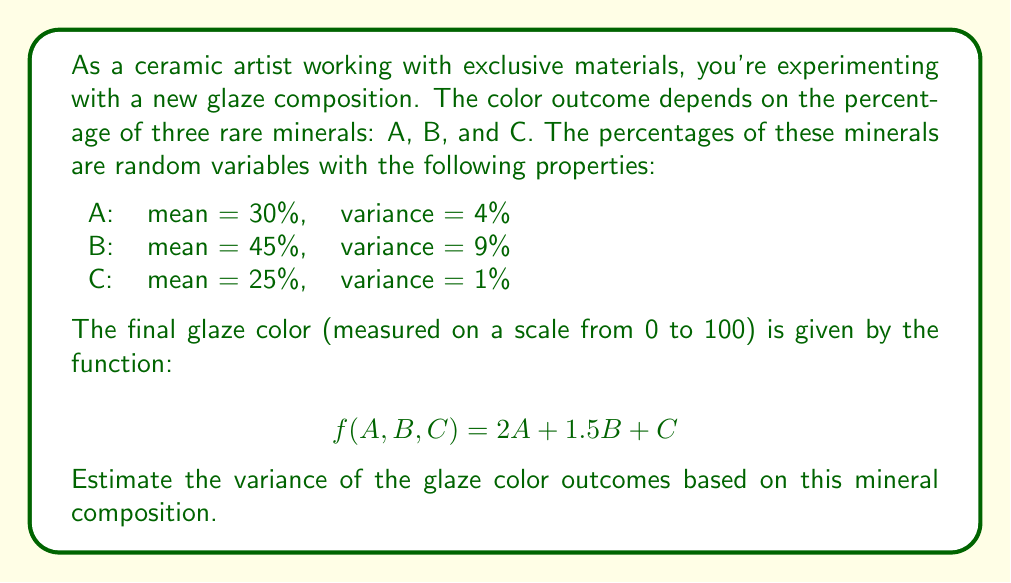Help me with this question. To solve this problem, we'll use the properties of variance for linear combinations of random variables. Let's approach this step-by-step:

1) The general formula for the variance of a linear combination of random variables is:

   $$Var(aX + bY + cZ) = a^2Var(X) + b^2Var(Y) + c^2Var(Z)$$

   This assumes that X, Y, and Z are independent.

2) In our case, we have:

   $$f(A,B,C) = 2A + 1.5B + C$$

3) Applying the formula:

   $$Var(f(A,B,C)) = Var(2A + 1.5B + C)$$
   $$= 2^2Var(A) + 1.5^2Var(B) + 1^2Var(C)$$

4) Now, let's substitute the given variances:

   $$Var(f(A,B,C)) = 2^2 * 4 + 1.5^2 * 9 + 1^2 * 1$$

5) Calculate:

   $$= 4 * 4 + 2.25 * 9 + 1$$
   $$= 16 + 20.25 + 1$$
   $$= 37.25$$

Therefore, the estimated variance of the glaze color outcomes is 37.25 (on a scale from 0 to 100).
Answer: 37.25 